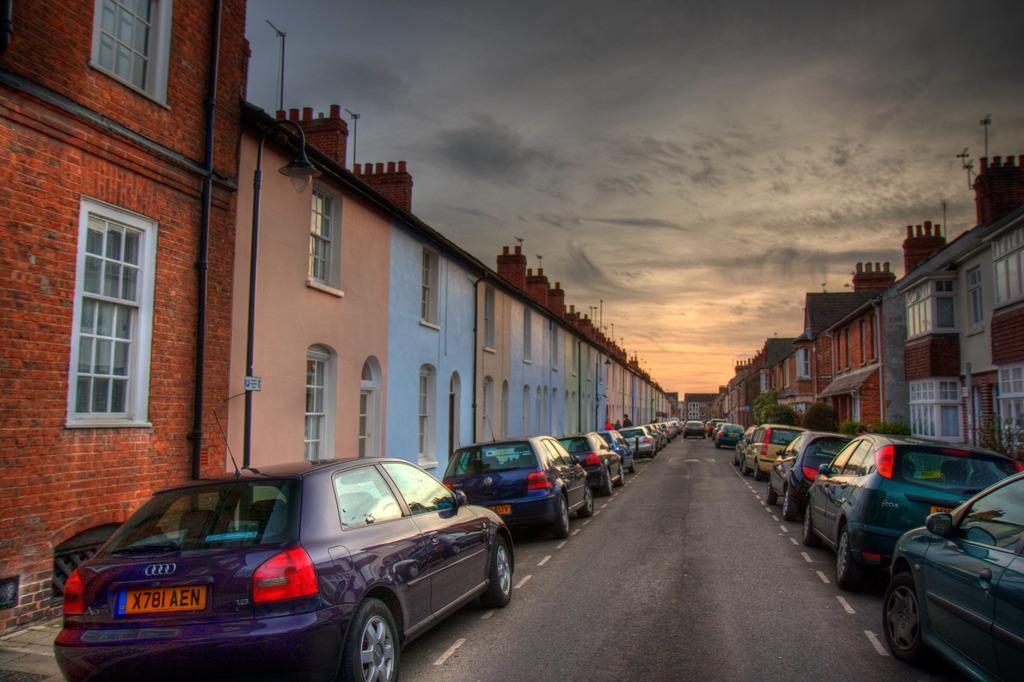What can be seen on the road in the image? There are many cars parked on the road in the image. What else is visible in the image besides the parked cars? There are buildings and poles visible in the image. How many drains can be seen in the image? There is no mention of drains in the image, so it is not possible to determine how many are present. 